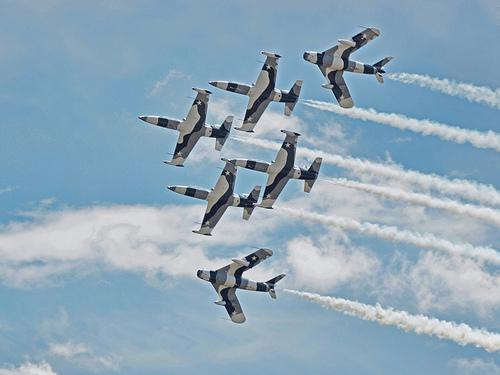Question: what color is the sky?
Choices:
A. Blue.
B. Grey.
C. Red.
D. Purple.
Answer with the letter. Answer: A Question: how many planes are in this picture?
Choices:
A. Five.
B. Four.
C. Seven.
D. Six.
Answer with the letter. Answer: D Question: who is flying the planes?
Choices:
A. Dog or Cat.
B. Men or women.
C. Horse or Donkey.
D. Snake or Beaver.
Answer with the letter. Answer: B Question: where does this picture take place?
Choices:
A. In the river.
B. In the sky.
C. On the sea.
D. In the house.
Answer with the letter. Answer: B 